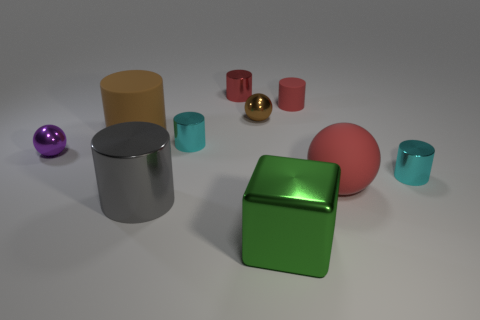What material is the tiny brown thing?
Offer a very short reply. Metal. Does the brown cylinder have the same material as the small cyan object that is to the left of the tiny red rubber thing?
Provide a succinct answer. No. There is a large brown thing that is the same shape as the tiny red metal object; what is its material?
Make the answer very short. Rubber. There is a tiny red metallic thing to the left of the big red matte sphere; how many brown matte things are in front of it?
Give a very brief answer. 1. Are there any other things that are the same color as the big matte sphere?
Ensure brevity in your answer.  Yes. How many objects are either brown things or tiny metallic cylinders that are left of the red ball?
Keep it short and to the point. 4. What is the material of the red ball that is in front of the tiny cyan metal cylinder on the right side of the rubber cylinder that is on the right side of the green block?
Provide a short and direct response. Rubber. The gray cylinder that is the same material as the big green block is what size?
Your answer should be very brief. Large. What is the color of the sphere to the left of the big metal object to the left of the cube?
Offer a very short reply. Purple. What number of tiny red things are the same material as the big red object?
Give a very brief answer. 1. 